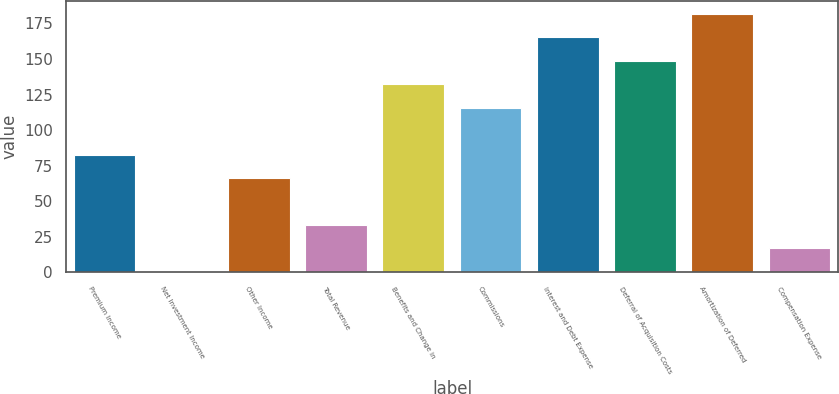Convert chart. <chart><loc_0><loc_0><loc_500><loc_500><bar_chart><fcel>Premium Income<fcel>Net Investment Income<fcel>Other Income<fcel>Total Revenue<fcel>Benefits and Change in<fcel>Commissions<fcel>Interest and Debt Expense<fcel>Deferral of Acquisition Costs<fcel>Amortization of Deferred<fcel>Compensation Expense<nl><fcel>82.85<fcel>0.4<fcel>66.36<fcel>33.38<fcel>132.32<fcel>115.83<fcel>165.3<fcel>148.81<fcel>181.79<fcel>16.89<nl></chart> 